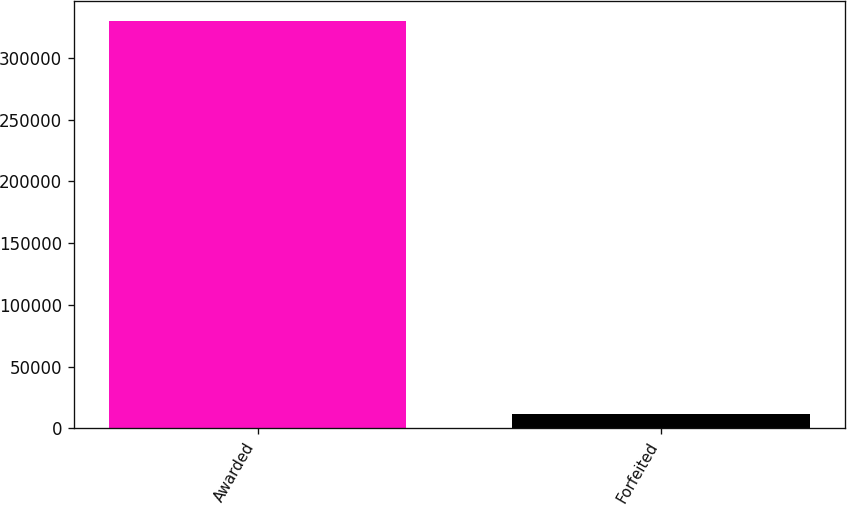<chart> <loc_0><loc_0><loc_500><loc_500><bar_chart><fcel>Awarded<fcel>Forfeited<nl><fcel>329500<fcel>12000<nl></chart> 